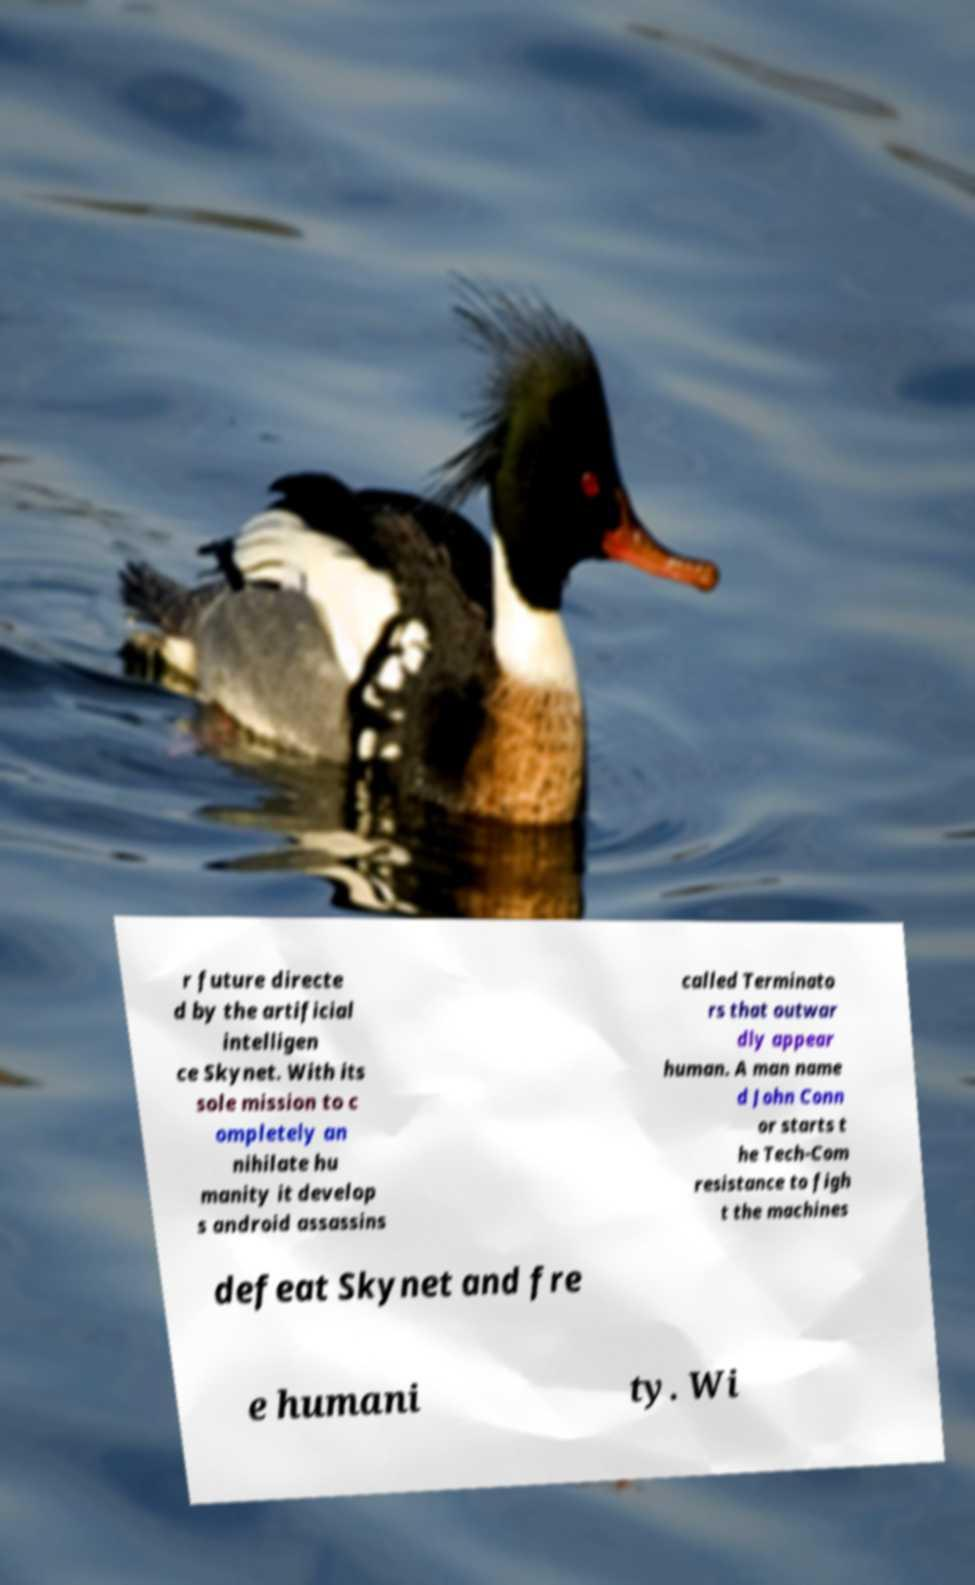Could you assist in decoding the text presented in this image and type it out clearly? r future directe d by the artificial intelligen ce Skynet. With its sole mission to c ompletely an nihilate hu manity it develop s android assassins called Terminato rs that outwar dly appear human. A man name d John Conn or starts t he Tech-Com resistance to figh t the machines defeat Skynet and fre e humani ty. Wi 